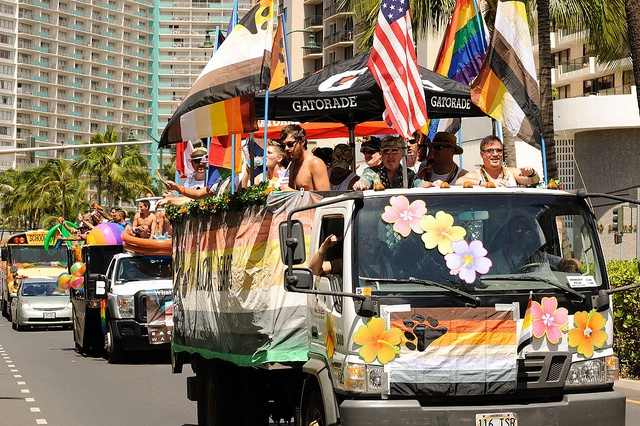Describe the objects in this image and their specific colors. I can see truck in tan, black, gray, white, and darkgray tones, truck in tan, black, white, gray, and darkgray tones, people in tan, black, gray, darkblue, and blue tones, umbrella in tan, black, gray, white, and darkgray tones, and bus in tan, gray, black, lightyellow, and khaki tones in this image. 